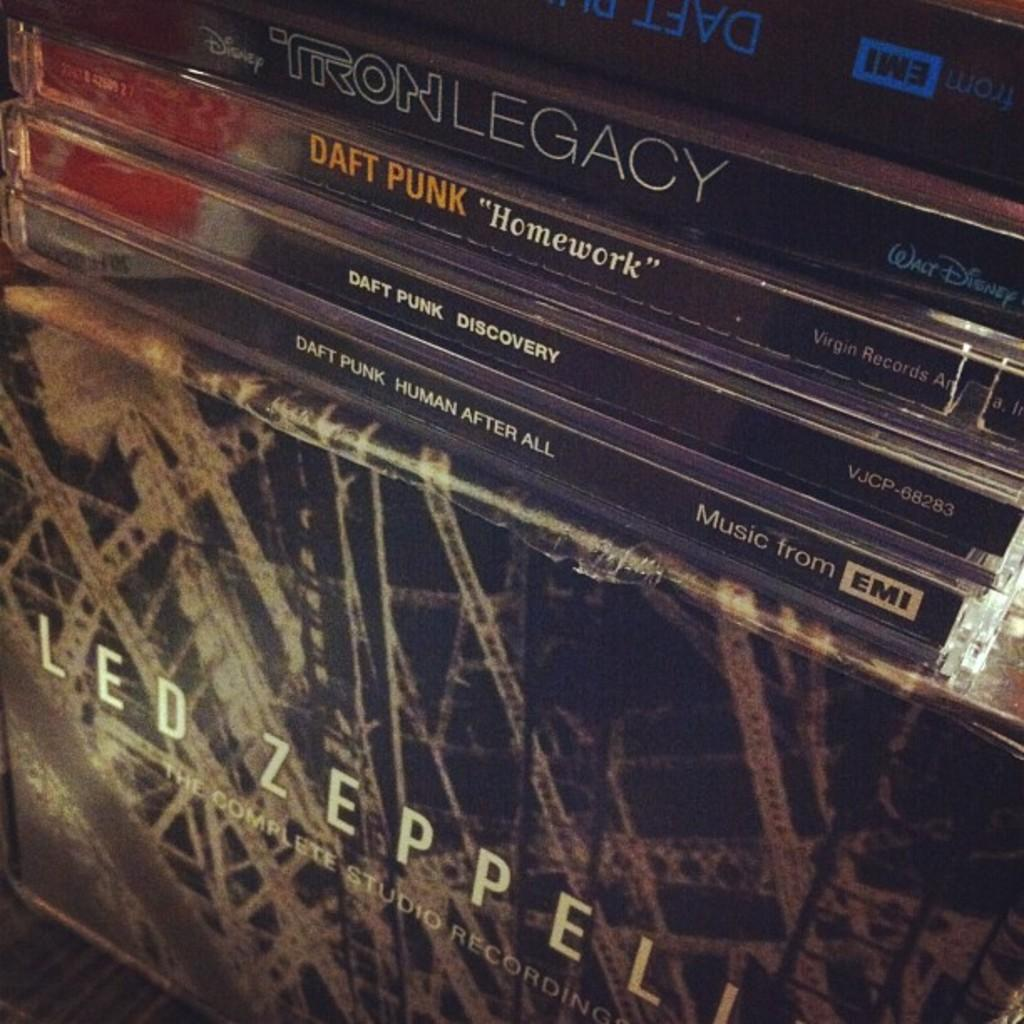<image>
Present a compact description of the photo's key features. A a stack of Daft Punk CD's are on a Led Zeplin box. 